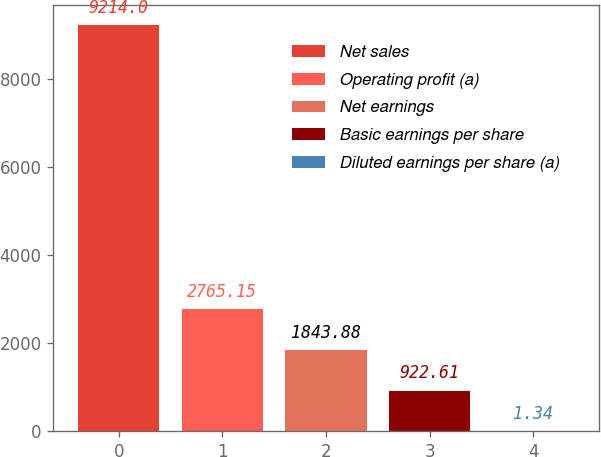<chart> <loc_0><loc_0><loc_500><loc_500><bar_chart><fcel>Net sales<fcel>Operating profit (a)<fcel>Net earnings<fcel>Basic earnings per share<fcel>Diluted earnings per share (a)<nl><fcel>9214<fcel>2765.15<fcel>1843.88<fcel>922.61<fcel>1.34<nl></chart> 